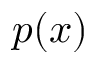Convert formula to latex. <formula><loc_0><loc_0><loc_500><loc_500>p ( x )</formula> 